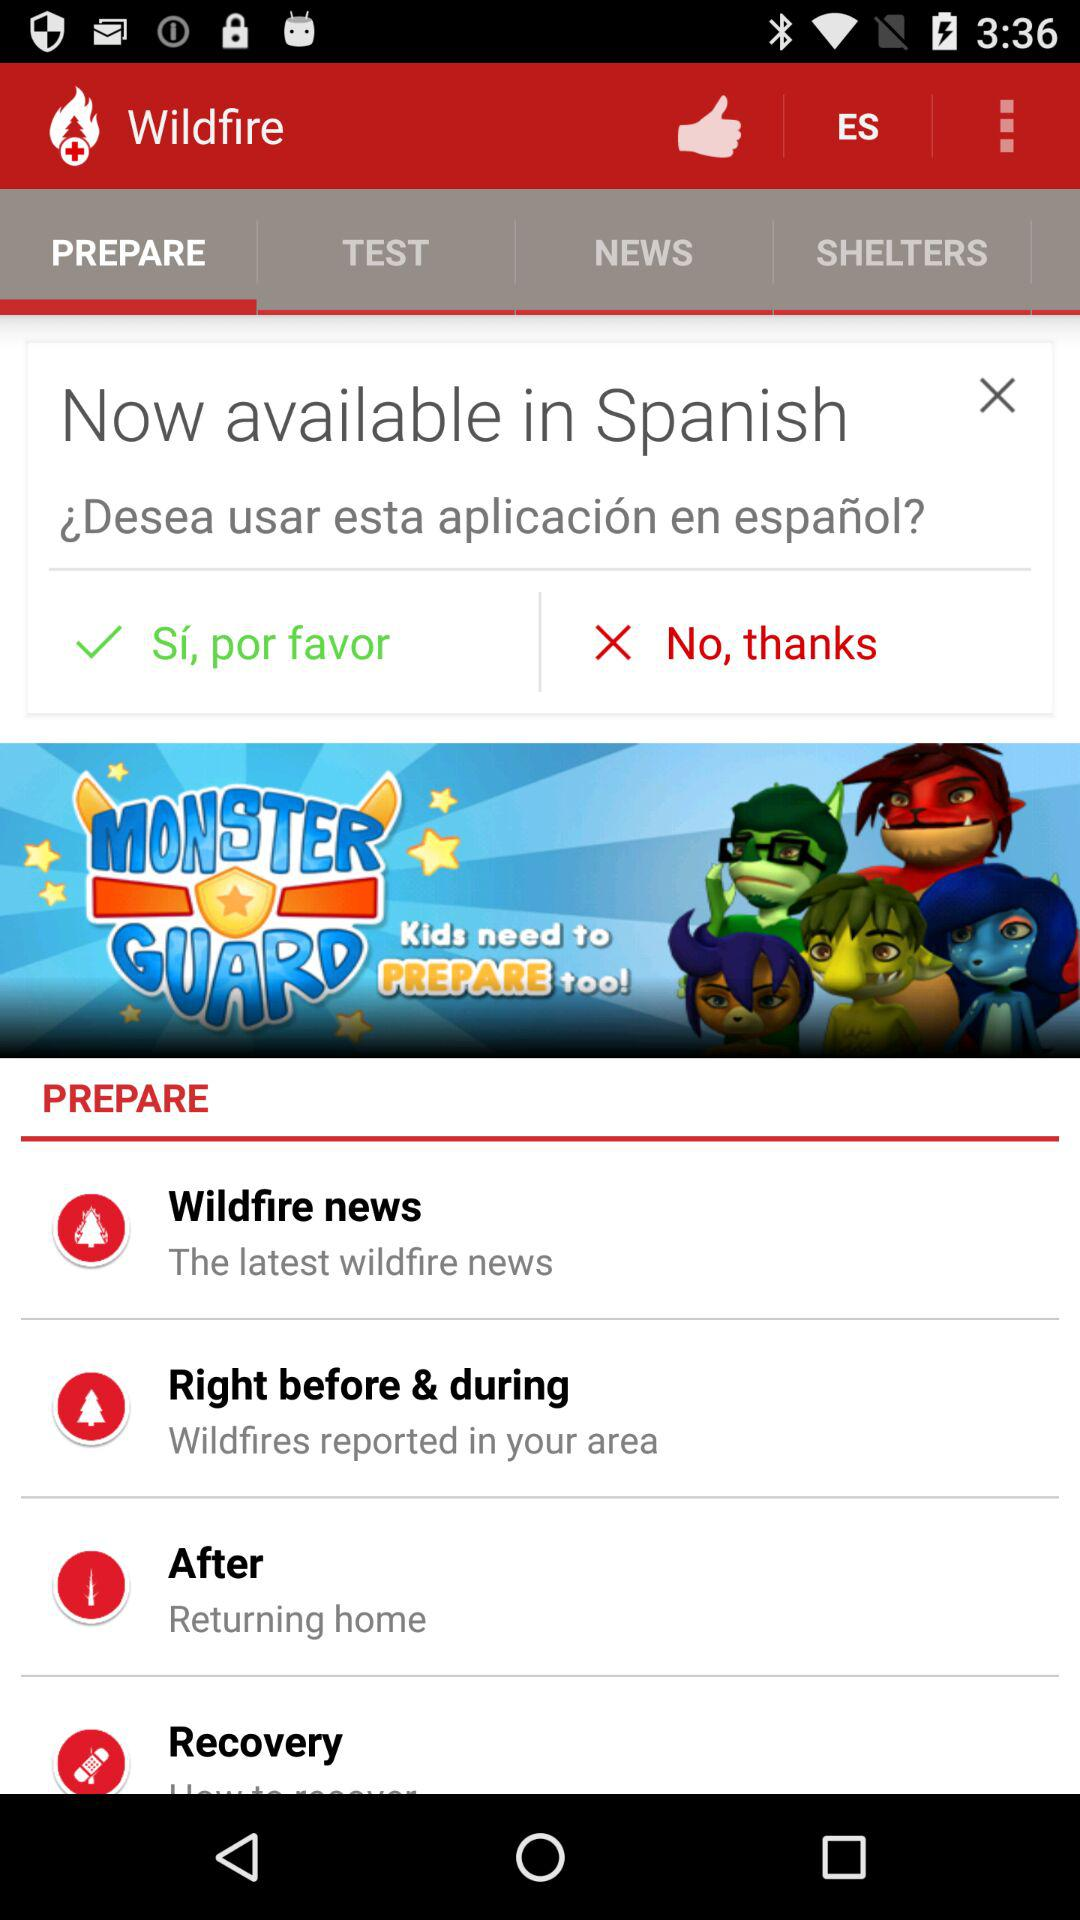Which option is selected in "Wildfire"? The selected option in "Wildfire" is "PREPARE". 